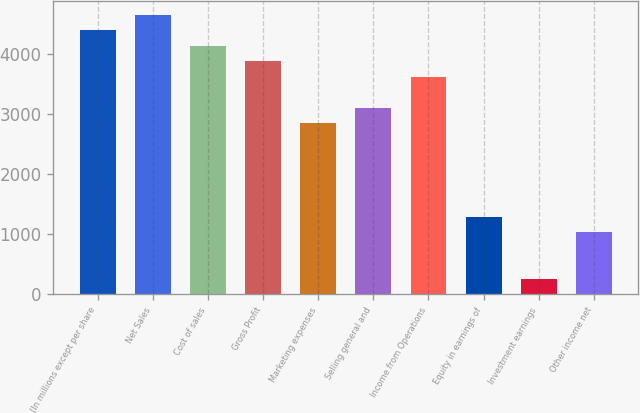Convert chart to OTSL. <chart><loc_0><loc_0><loc_500><loc_500><bar_chart><fcel>(In millions except per share<fcel>Net Sales<fcel>Cost of sales<fcel>Gross Profit<fcel>Marketing expenses<fcel>Selling general and<fcel>Income from Operations<fcel>Equity in earnings of<fcel>Investment earnings<fcel>Other income net<nl><fcel>4401.44<fcel>4660.33<fcel>4142.55<fcel>3883.66<fcel>2848.1<fcel>3106.99<fcel>3624.77<fcel>1294.76<fcel>259.2<fcel>1035.87<nl></chart> 